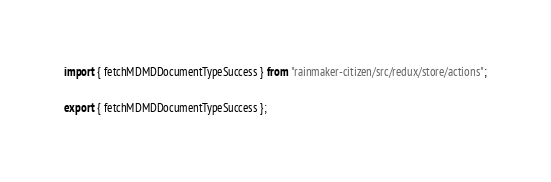<code> <loc_0><loc_0><loc_500><loc_500><_JavaScript_>import { fetchMDMDDocumentTypeSuccess } from "rainmaker-citizen/src/redux/store/actions";

export { fetchMDMDDocumentTypeSuccess };
</code> 